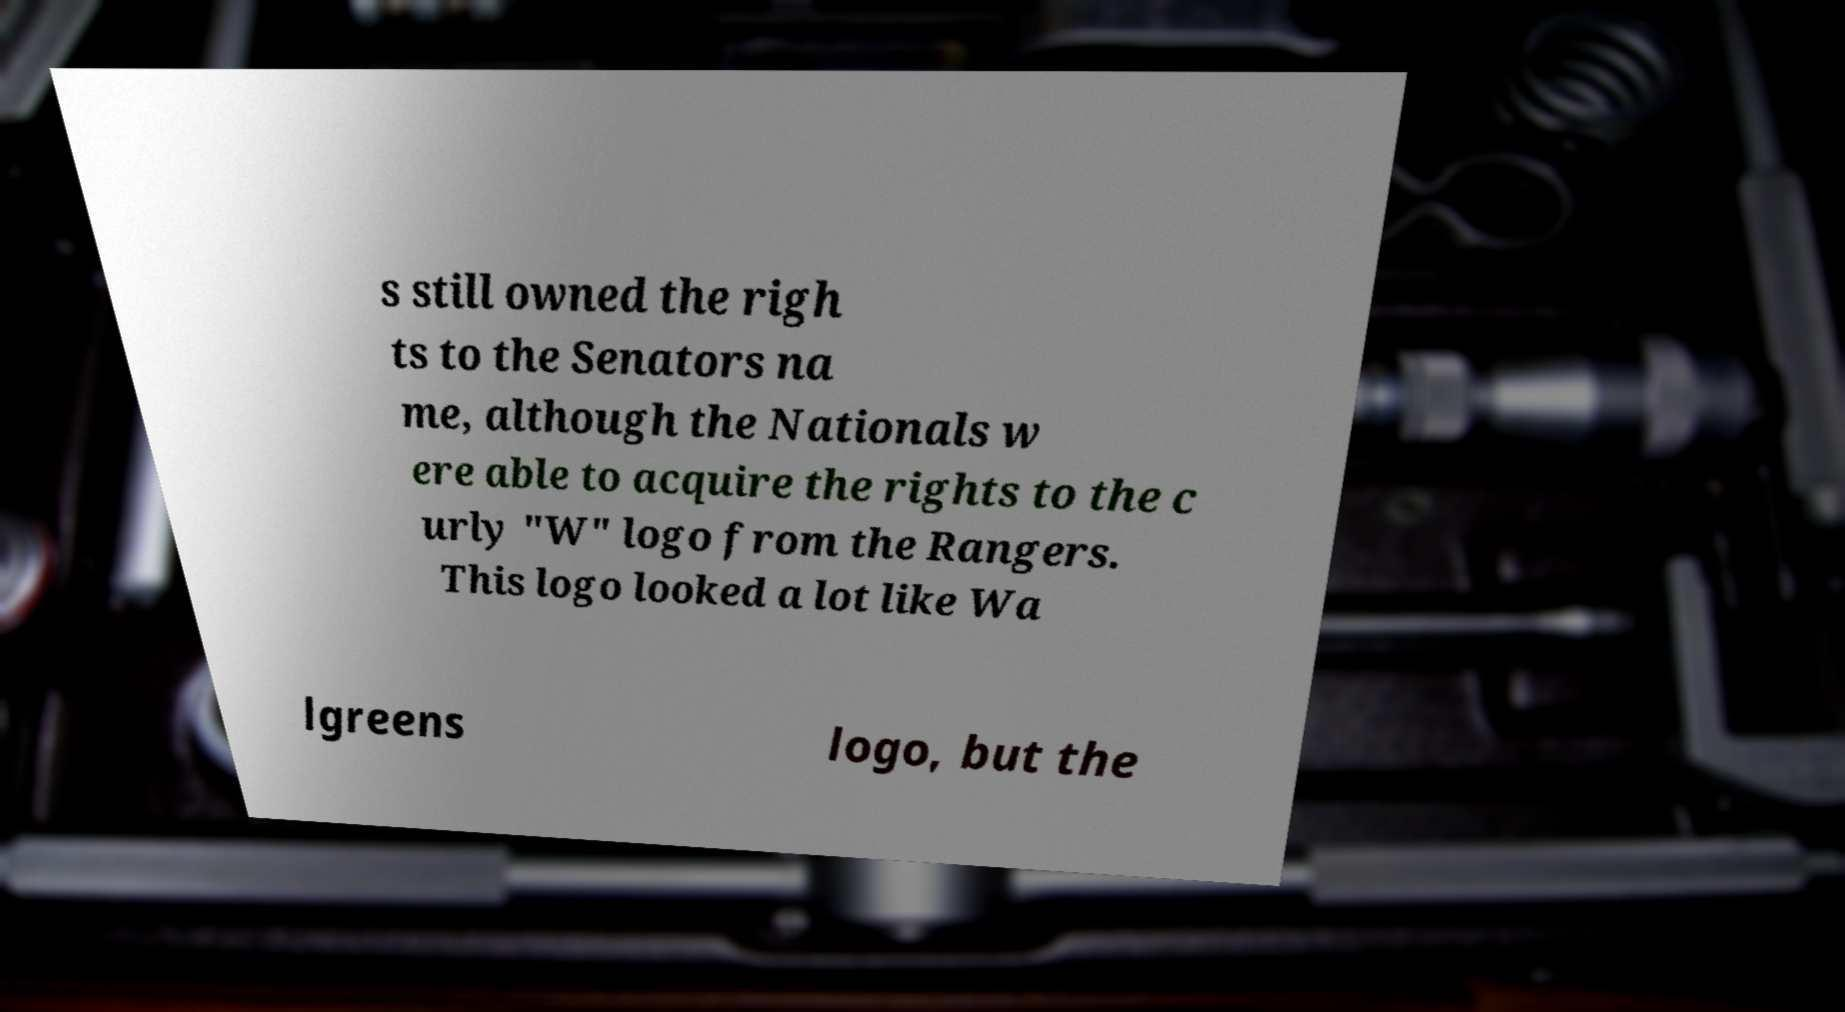Please identify and transcribe the text found in this image. s still owned the righ ts to the Senators na me, although the Nationals w ere able to acquire the rights to the c urly "W" logo from the Rangers. This logo looked a lot like Wa lgreens logo, but the 